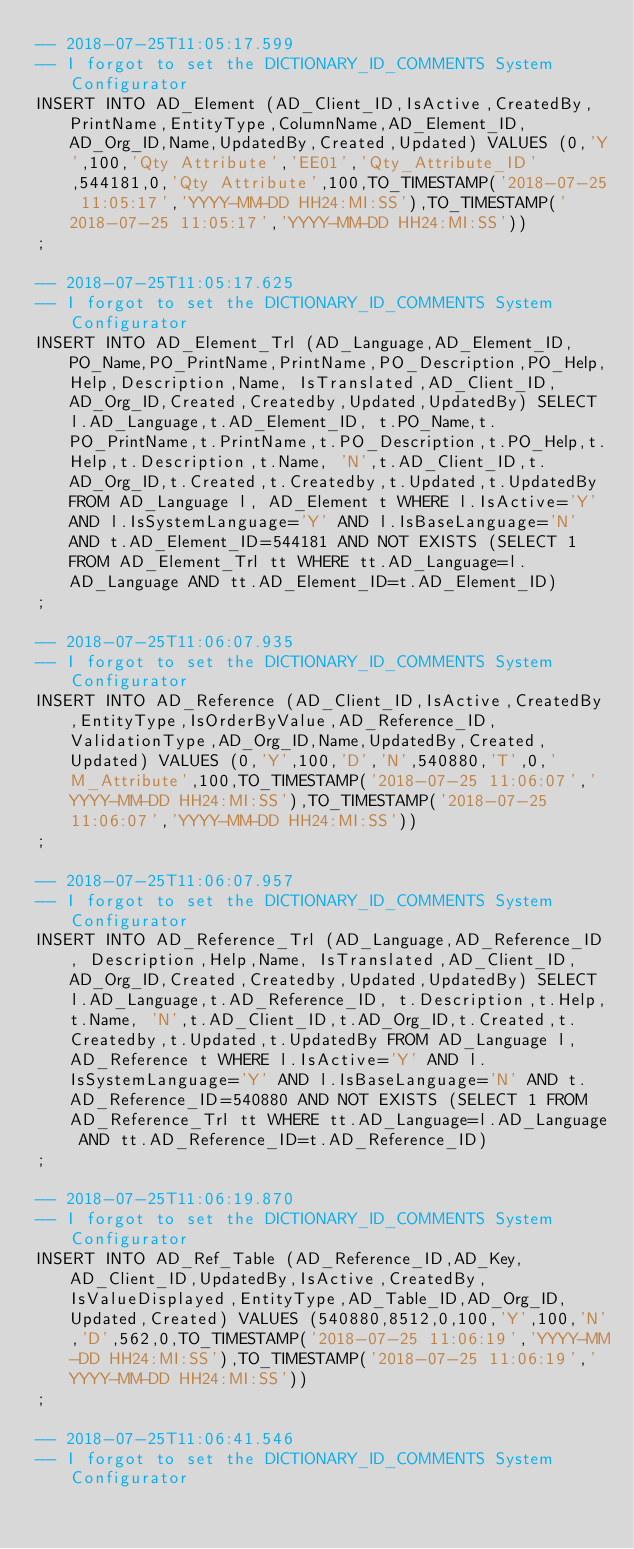Convert code to text. <code><loc_0><loc_0><loc_500><loc_500><_SQL_>-- 2018-07-25T11:05:17.599
-- I forgot to set the DICTIONARY_ID_COMMENTS System Configurator
INSERT INTO AD_Element (AD_Client_ID,IsActive,CreatedBy,PrintName,EntityType,ColumnName,AD_Element_ID,AD_Org_ID,Name,UpdatedBy,Created,Updated) VALUES (0,'Y',100,'Qty Attribute','EE01','Qty_Attribute_ID',544181,0,'Qty Attribute',100,TO_TIMESTAMP('2018-07-25 11:05:17','YYYY-MM-DD HH24:MI:SS'),TO_TIMESTAMP('2018-07-25 11:05:17','YYYY-MM-DD HH24:MI:SS'))
;

-- 2018-07-25T11:05:17.625
-- I forgot to set the DICTIONARY_ID_COMMENTS System Configurator
INSERT INTO AD_Element_Trl (AD_Language,AD_Element_ID, PO_Name,PO_PrintName,PrintName,PO_Description,PO_Help,Help,Description,Name, IsTranslated,AD_Client_ID,AD_Org_ID,Created,Createdby,Updated,UpdatedBy) SELECT l.AD_Language,t.AD_Element_ID, t.PO_Name,t.PO_PrintName,t.PrintName,t.PO_Description,t.PO_Help,t.Help,t.Description,t.Name, 'N',t.AD_Client_ID,t.AD_Org_ID,t.Created,t.Createdby,t.Updated,t.UpdatedBy FROM AD_Language l, AD_Element t WHERE l.IsActive='Y' AND l.IsSystemLanguage='Y' AND l.IsBaseLanguage='N' AND t.AD_Element_ID=544181 AND NOT EXISTS (SELECT 1 FROM AD_Element_Trl tt WHERE tt.AD_Language=l.AD_Language AND tt.AD_Element_ID=t.AD_Element_ID)
;

-- 2018-07-25T11:06:07.935
-- I forgot to set the DICTIONARY_ID_COMMENTS System Configurator
INSERT INTO AD_Reference (AD_Client_ID,IsActive,CreatedBy,EntityType,IsOrderByValue,AD_Reference_ID,ValidationType,AD_Org_ID,Name,UpdatedBy,Created,Updated) VALUES (0,'Y',100,'D','N',540880,'T',0,'M_Attribute',100,TO_TIMESTAMP('2018-07-25 11:06:07','YYYY-MM-DD HH24:MI:SS'),TO_TIMESTAMP('2018-07-25 11:06:07','YYYY-MM-DD HH24:MI:SS'))
;

-- 2018-07-25T11:06:07.957
-- I forgot to set the DICTIONARY_ID_COMMENTS System Configurator
INSERT INTO AD_Reference_Trl (AD_Language,AD_Reference_ID, Description,Help,Name, IsTranslated,AD_Client_ID,AD_Org_ID,Created,Createdby,Updated,UpdatedBy) SELECT l.AD_Language,t.AD_Reference_ID, t.Description,t.Help,t.Name, 'N',t.AD_Client_ID,t.AD_Org_ID,t.Created,t.Createdby,t.Updated,t.UpdatedBy FROM AD_Language l, AD_Reference t WHERE l.IsActive='Y' AND l.IsSystemLanguage='Y' AND l.IsBaseLanguage='N' AND t.AD_Reference_ID=540880 AND NOT EXISTS (SELECT 1 FROM AD_Reference_Trl tt WHERE tt.AD_Language=l.AD_Language AND tt.AD_Reference_ID=t.AD_Reference_ID)
;

-- 2018-07-25T11:06:19.870
-- I forgot to set the DICTIONARY_ID_COMMENTS System Configurator
INSERT INTO AD_Ref_Table (AD_Reference_ID,AD_Key,AD_Client_ID,UpdatedBy,IsActive,CreatedBy,IsValueDisplayed,EntityType,AD_Table_ID,AD_Org_ID,Updated,Created) VALUES (540880,8512,0,100,'Y',100,'N','D',562,0,TO_TIMESTAMP('2018-07-25 11:06:19','YYYY-MM-DD HH24:MI:SS'),TO_TIMESTAMP('2018-07-25 11:06:19','YYYY-MM-DD HH24:MI:SS'))
;

-- 2018-07-25T11:06:41.546
-- I forgot to set the DICTIONARY_ID_COMMENTS System Configurator</code> 